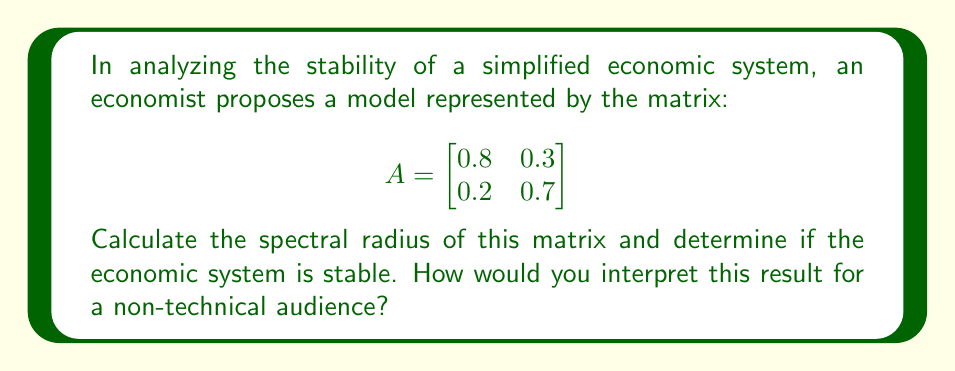Teach me how to tackle this problem. To evaluate the stability of the economic system using the spectral radius:

1) First, we need to find the eigenvalues of matrix A. The characteristic equation is:

   $det(A - \lambda I) = 0$

   $\begin{vmatrix}
   0.8 - \lambda & 0.3 \\
   0.2 & 0.7 - \lambda
   \end{vmatrix} = 0$

2) Expanding the determinant:

   $(0.8 - \lambda)(0.7 - \lambda) - 0.06 = 0$
   $\lambda^2 - 1.5\lambda + 0.5 = 0$

3) Solving this quadratic equation:

   $\lambda = \frac{1.5 \pm \sqrt{1.5^2 - 4(0.5)}}{2}$
   $\lambda = \frac{1.5 \pm \sqrt{1.25}}{2}$
   $\lambda_1 = 1$ and $\lambda_2 = 0.5$

4) The spectral radius $\rho(A)$ is the maximum absolute value of the eigenvalues:

   $\rho(A) = max(|\lambda_1|, |\lambda_2|) = max(1, 0.5) = 1$

5) For stability, we require $\rho(A) < 1$. Since $\rho(A) = 1$, the system is at the boundary of stability.

Interpretation for a non-technical audience: The spectral radius of 1 suggests that the economic system is neither growing nor shrinking over time, but rather maintaining a steady state. However, this equilibrium is delicate, and any small perturbation could potentially lead to instability. It's like a ball balanced on the peak of a hill – it's stable for now, but even a slight push could cause it to roll down in either direction.
Answer: The spectral radius is 1, indicating the system is at the boundary of stability. 